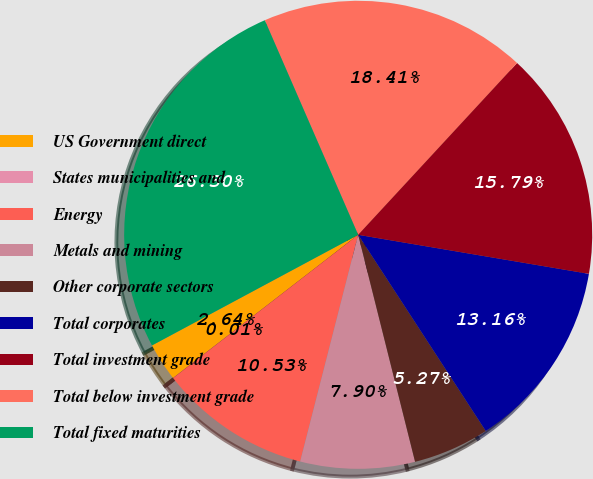Convert chart to OTSL. <chart><loc_0><loc_0><loc_500><loc_500><pie_chart><fcel>US Government direct<fcel>States municipalities and<fcel>Energy<fcel>Metals and mining<fcel>Other corporate sectors<fcel>Total corporates<fcel>Total investment grade<fcel>Total below investment grade<fcel>Total fixed maturities<nl><fcel>2.64%<fcel>0.01%<fcel>10.53%<fcel>7.9%<fcel>5.27%<fcel>13.16%<fcel>15.79%<fcel>18.42%<fcel>26.31%<nl></chart> 